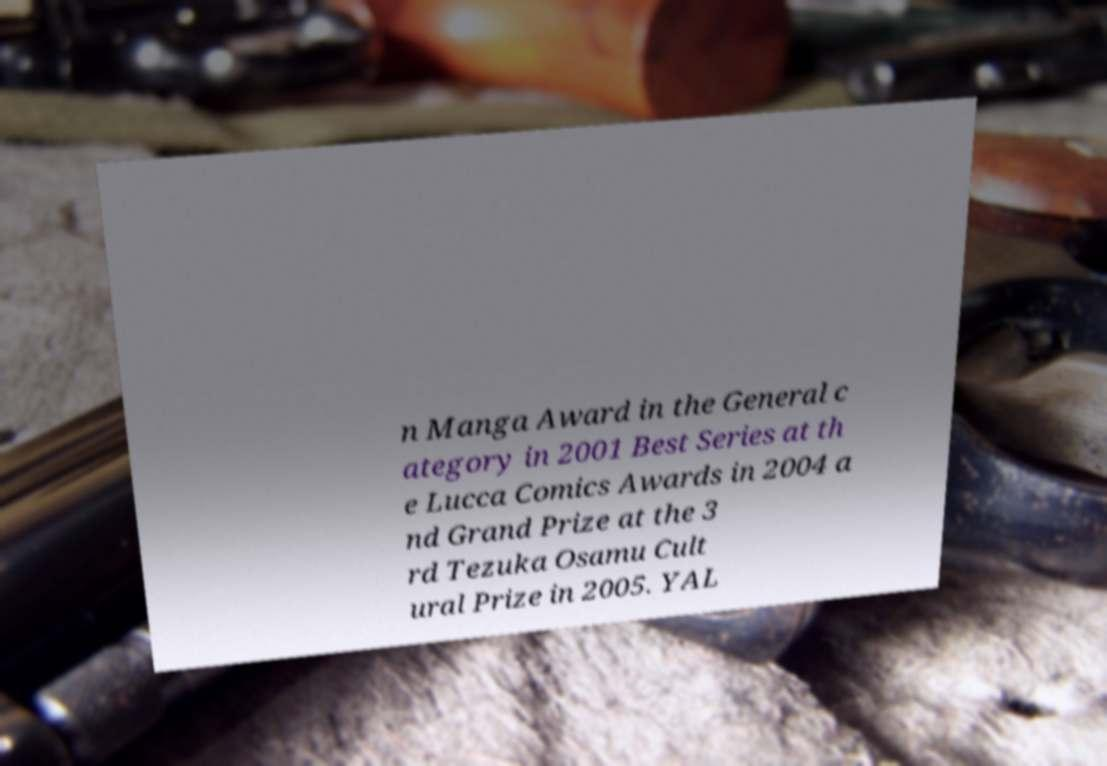Please identify and transcribe the text found in this image. n Manga Award in the General c ategory in 2001 Best Series at th e Lucca Comics Awards in 2004 a nd Grand Prize at the 3 rd Tezuka Osamu Cult ural Prize in 2005. YAL 